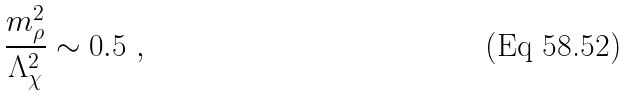<formula> <loc_0><loc_0><loc_500><loc_500>\frac { m _ { \rho } ^ { 2 } } { \Lambda _ { \chi } ^ { 2 } } \sim 0 . 5 \ ,</formula> 